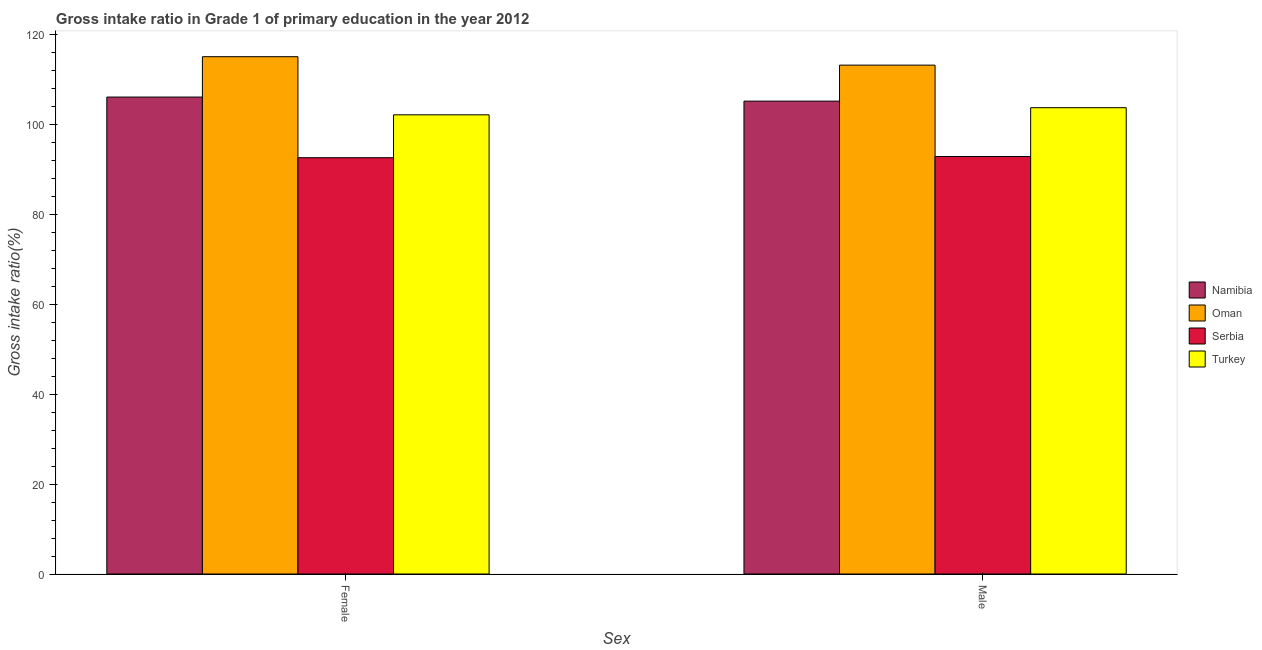How many different coloured bars are there?
Your answer should be compact. 4. How many groups of bars are there?
Provide a succinct answer. 2. How many bars are there on the 1st tick from the right?
Offer a terse response. 4. What is the label of the 1st group of bars from the left?
Your answer should be very brief. Female. What is the gross intake ratio(female) in Oman?
Give a very brief answer. 115.07. Across all countries, what is the maximum gross intake ratio(female)?
Provide a succinct answer. 115.07. Across all countries, what is the minimum gross intake ratio(male)?
Offer a terse response. 92.86. In which country was the gross intake ratio(male) maximum?
Keep it short and to the point. Oman. In which country was the gross intake ratio(female) minimum?
Give a very brief answer. Serbia. What is the total gross intake ratio(female) in the graph?
Provide a short and direct response. 415.89. What is the difference between the gross intake ratio(male) in Serbia and that in Oman?
Offer a terse response. -20.33. What is the difference between the gross intake ratio(female) in Oman and the gross intake ratio(male) in Namibia?
Make the answer very short. 9.88. What is the average gross intake ratio(female) per country?
Keep it short and to the point. 103.97. What is the difference between the gross intake ratio(male) and gross intake ratio(female) in Namibia?
Keep it short and to the point. -0.91. What is the ratio of the gross intake ratio(male) in Oman to that in Namibia?
Provide a succinct answer. 1.08. Is the gross intake ratio(female) in Serbia less than that in Oman?
Your answer should be very brief. Yes. What does the 3rd bar from the left in Male represents?
Your answer should be very brief. Serbia. What does the 2nd bar from the right in Female represents?
Your answer should be compact. Serbia. How many bars are there?
Provide a short and direct response. 8. What is the difference between two consecutive major ticks on the Y-axis?
Make the answer very short. 20. Does the graph contain any zero values?
Your answer should be very brief. No. How are the legend labels stacked?
Your answer should be very brief. Vertical. What is the title of the graph?
Offer a terse response. Gross intake ratio in Grade 1 of primary education in the year 2012. Does "Malawi" appear as one of the legend labels in the graph?
Provide a succinct answer. No. What is the label or title of the X-axis?
Provide a succinct answer. Sex. What is the label or title of the Y-axis?
Give a very brief answer. Gross intake ratio(%). What is the Gross intake ratio(%) in Namibia in Female?
Your answer should be compact. 106.09. What is the Gross intake ratio(%) in Oman in Female?
Your answer should be compact. 115.07. What is the Gross intake ratio(%) in Serbia in Female?
Provide a short and direct response. 92.6. What is the Gross intake ratio(%) of Turkey in Female?
Ensure brevity in your answer.  102.14. What is the Gross intake ratio(%) in Namibia in Male?
Give a very brief answer. 105.18. What is the Gross intake ratio(%) in Oman in Male?
Provide a succinct answer. 113.19. What is the Gross intake ratio(%) in Serbia in Male?
Provide a short and direct response. 92.86. What is the Gross intake ratio(%) in Turkey in Male?
Provide a short and direct response. 103.72. Across all Sex, what is the maximum Gross intake ratio(%) in Namibia?
Ensure brevity in your answer.  106.09. Across all Sex, what is the maximum Gross intake ratio(%) in Oman?
Provide a succinct answer. 115.07. Across all Sex, what is the maximum Gross intake ratio(%) of Serbia?
Keep it short and to the point. 92.86. Across all Sex, what is the maximum Gross intake ratio(%) of Turkey?
Make the answer very short. 103.72. Across all Sex, what is the minimum Gross intake ratio(%) in Namibia?
Your answer should be compact. 105.18. Across all Sex, what is the minimum Gross intake ratio(%) in Oman?
Your response must be concise. 113.19. Across all Sex, what is the minimum Gross intake ratio(%) in Serbia?
Give a very brief answer. 92.6. Across all Sex, what is the minimum Gross intake ratio(%) in Turkey?
Make the answer very short. 102.14. What is the total Gross intake ratio(%) of Namibia in the graph?
Your response must be concise. 211.27. What is the total Gross intake ratio(%) of Oman in the graph?
Your answer should be compact. 228.25. What is the total Gross intake ratio(%) of Serbia in the graph?
Provide a succinct answer. 185.46. What is the total Gross intake ratio(%) in Turkey in the graph?
Give a very brief answer. 205.86. What is the difference between the Gross intake ratio(%) of Namibia in Female and that in Male?
Offer a very short reply. 0.91. What is the difference between the Gross intake ratio(%) of Oman in Female and that in Male?
Give a very brief answer. 1.88. What is the difference between the Gross intake ratio(%) of Serbia in Female and that in Male?
Your answer should be compact. -0.26. What is the difference between the Gross intake ratio(%) of Turkey in Female and that in Male?
Offer a terse response. -1.58. What is the difference between the Gross intake ratio(%) of Namibia in Female and the Gross intake ratio(%) of Oman in Male?
Offer a terse response. -7.1. What is the difference between the Gross intake ratio(%) in Namibia in Female and the Gross intake ratio(%) in Serbia in Male?
Provide a succinct answer. 13.23. What is the difference between the Gross intake ratio(%) of Namibia in Female and the Gross intake ratio(%) of Turkey in Male?
Your answer should be very brief. 2.37. What is the difference between the Gross intake ratio(%) in Oman in Female and the Gross intake ratio(%) in Serbia in Male?
Ensure brevity in your answer.  22.21. What is the difference between the Gross intake ratio(%) of Oman in Female and the Gross intake ratio(%) of Turkey in Male?
Ensure brevity in your answer.  11.35. What is the difference between the Gross intake ratio(%) of Serbia in Female and the Gross intake ratio(%) of Turkey in Male?
Offer a terse response. -11.12. What is the average Gross intake ratio(%) of Namibia per Sex?
Your answer should be compact. 105.63. What is the average Gross intake ratio(%) of Oman per Sex?
Ensure brevity in your answer.  114.13. What is the average Gross intake ratio(%) in Serbia per Sex?
Give a very brief answer. 92.73. What is the average Gross intake ratio(%) in Turkey per Sex?
Offer a terse response. 102.93. What is the difference between the Gross intake ratio(%) of Namibia and Gross intake ratio(%) of Oman in Female?
Ensure brevity in your answer.  -8.98. What is the difference between the Gross intake ratio(%) of Namibia and Gross intake ratio(%) of Serbia in Female?
Offer a very short reply. 13.49. What is the difference between the Gross intake ratio(%) in Namibia and Gross intake ratio(%) in Turkey in Female?
Your answer should be compact. 3.95. What is the difference between the Gross intake ratio(%) of Oman and Gross intake ratio(%) of Serbia in Female?
Your response must be concise. 22.47. What is the difference between the Gross intake ratio(%) of Oman and Gross intake ratio(%) of Turkey in Female?
Provide a short and direct response. 12.93. What is the difference between the Gross intake ratio(%) of Serbia and Gross intake ratio(%) of Turkey in Female?
Provide a succinct answer. -9.54. What is the difference between the Gross intake ratio(%) in Namibia and Gross intake ratio(%) in Oman in Male?
Offer a terse response. -8.01. What is the difference between the Gross intake ratio(%) in Namibia and Gross intake ratio(%) in Serbia in Male?
Ensure brevity in your answer.  12.32. What is the difference between the Gross intake ratio(%) in Namibia and Gross intake ratio(%) in Turkey in Male?
Give a very brief answer. 1.46. What is the difference between the Gross intake ratio(%) of Oman and Gross intake ratio(%) of Serbia in Male?
Offer a very short reply. 20.33. What is the difference between the Gross intake ratio(%) in Oman and Gross intake ratio(%) in Turkey in Male?
Give a very brief answer. 9.47. What is the difference between the Gross intake ratio(%) of Serbia and Gross intake ratio(%) of Turkey in Male?
Provide a succinct answer. -10.86. What is the ratio of the Gross intake ratio(%) in Namibia in Female to that in Male?
Provide a succinct answer. 1.01. What is the ratio of the Gross intake ratio(%) in Oman in Female to that in Male?
Give a very brief answer. 1.02. What is the ratio of the Gross intake ratio(%) in Turkey in Female to that in Male?
Provide a succinct answer. 0.98. What is the difference between the highest and the second highest Gross intake ratio(%) of Namibia?
Your answer should be very brief. 0.91. What is the difference between the highest and the second highest Gross intake ratio(%) in Oman?
Offer a very short reply. 1.88. What is the difference between the highest and the second highest Gross intake ratio(%) of Serbia?
Offer a terse response. 0.26. What is the difference between the highest and the second highest Gross intake ratio(%) in Turkey?
Offer a terse response. 1.58. What is the difference between the highest and the lowest Gross intake ratio(%) of Namibia?
Provide a succinct answer. 0.91. What is the difference between the highest and the lowest Gross intake ratio(%) in Oman?
Offer a terse response. 1.88. What is the difference between the highest and the lowest Gross intake ratio(%) of Serbia?
Your answer should be compact. 0.26. What is the difference between the highest and the lowest Gross intake ratio(%) of Turkey?
Your answer should be compact. 1.58. 